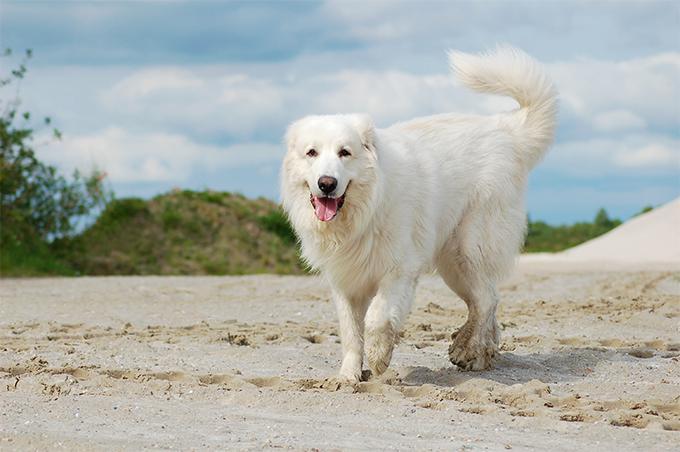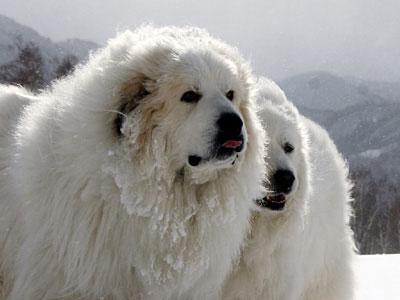The first image is the image on the left, the second image is the image on the right. For the images shown, is this caption "There are three dogs in total." true? Answer yes or no. Yes. 